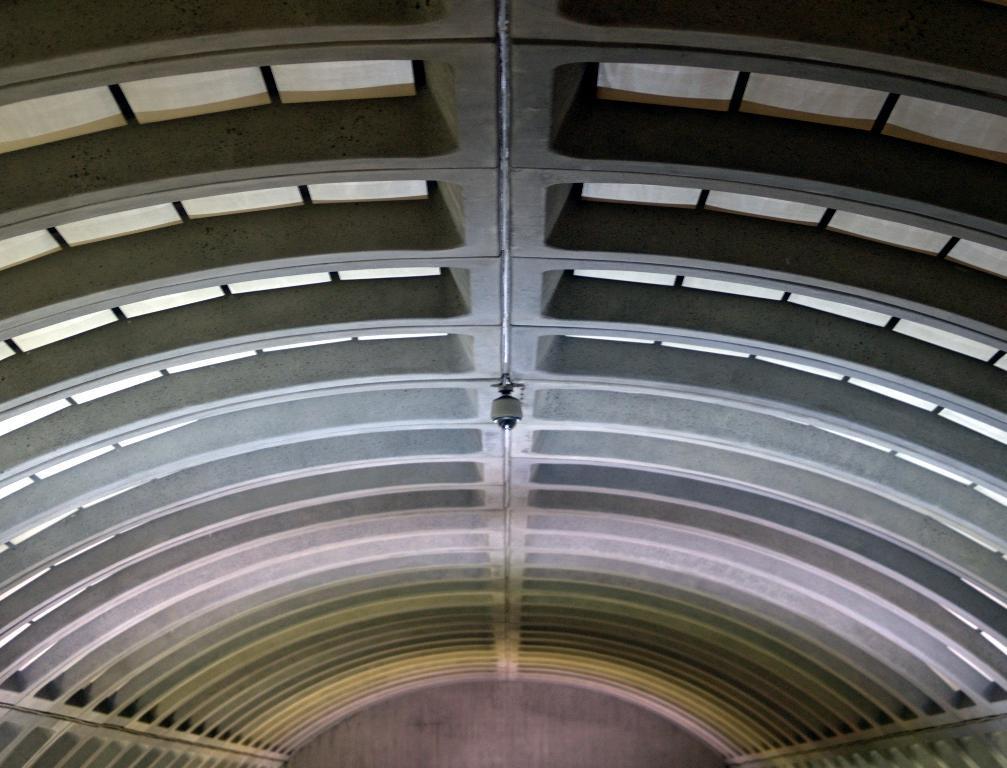Describe this image in one or two sentences. In this image I can see a building and I can also see a pole. 